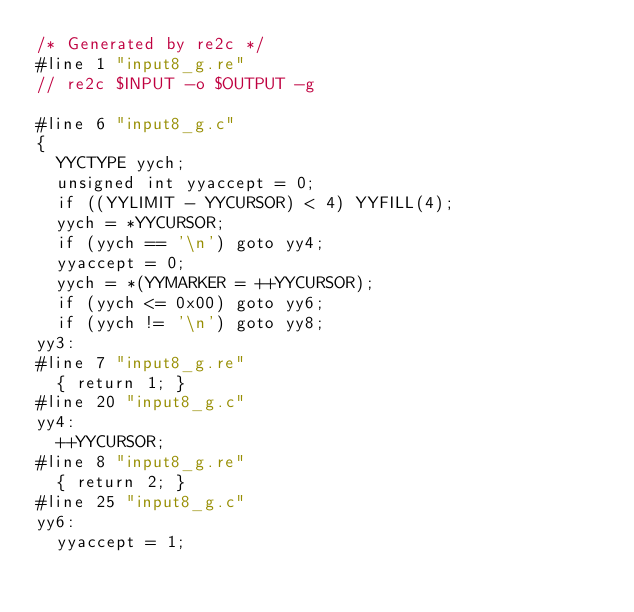<code> <loc_0><loc_0><loc_500><loc_500><_C_>/* Generated by re2c */
#line 1 "input8_g.re"
// re2c $INPUT -o $OUTPUT -g

#line 6 "input8_g.c"
{
	YYCTYPE yych;
	unsigned int yyaccept = 0;
	if ((YYLIMIT - YYCURSOR) < 4) YYFILL(4);
	yych = *YYCURSOR;
	if (yych == '\n') goto yy4;
	yyaccept = 0;
	yych = *(YYMARKER = ++YYCURSOR);
	if (yych <= 0x00) goto yy6;
	if (yych != '\n') goto yy8;
yy3:
#line 7 "input8_g.re"
	{ return 1; }
#line 20 "input8_g.c"
yy4:
	++YYCURSOR;
#line 8 "input8_g.re"
	{ return 2; }
#line 25 "input8_g.c"
yy6:
	yyaccept = 1;</code> 